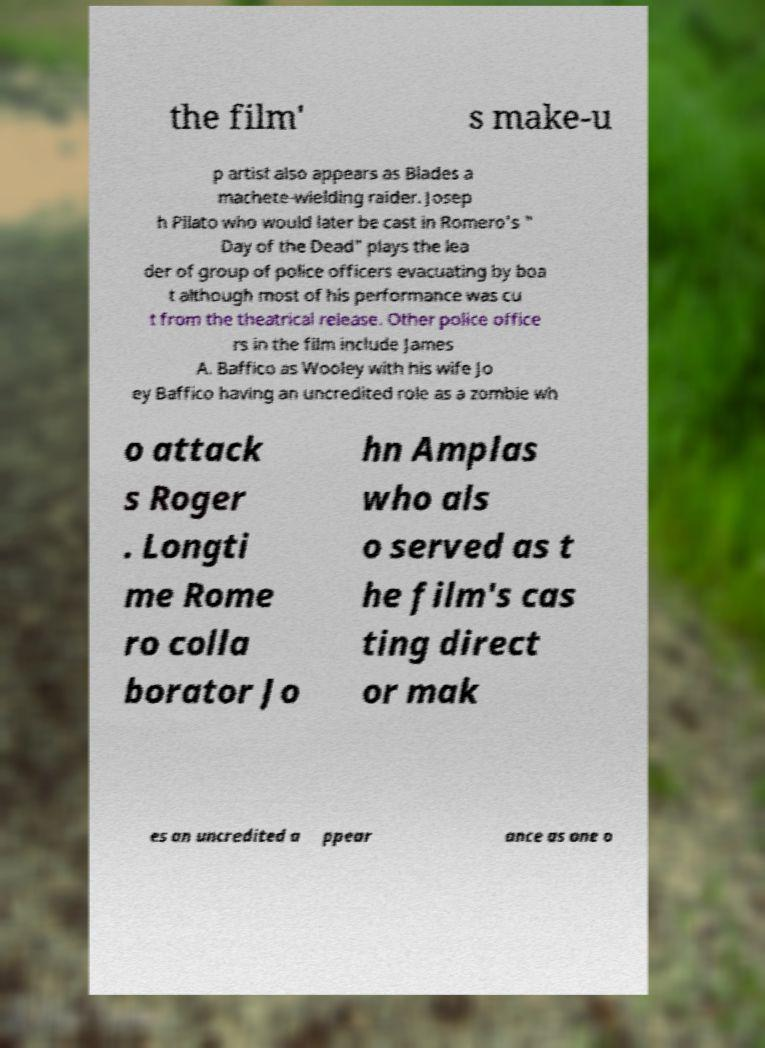What messages or text are displayed in this image? I need them in a readable, typed format. the film' s make-u p artist also appears as Blades a machete-wielding raider. Josep h Pilato who would later be cast in Romero's " Day of the Dead" plays the lea der of group of police officers evacuating by boa t although most of his performance was cu t from the theatrical release. Other police office rs in the film include James A. Baffico as Wooley with his wife Jo ey Baffico having an uncredited role as a zombie wh o attack s Roger . Longti me Rome ro colla borator Jo hn Amplas who als o served as t he film's cas ting direct or mak es an uncredited a ppear ance as one o 